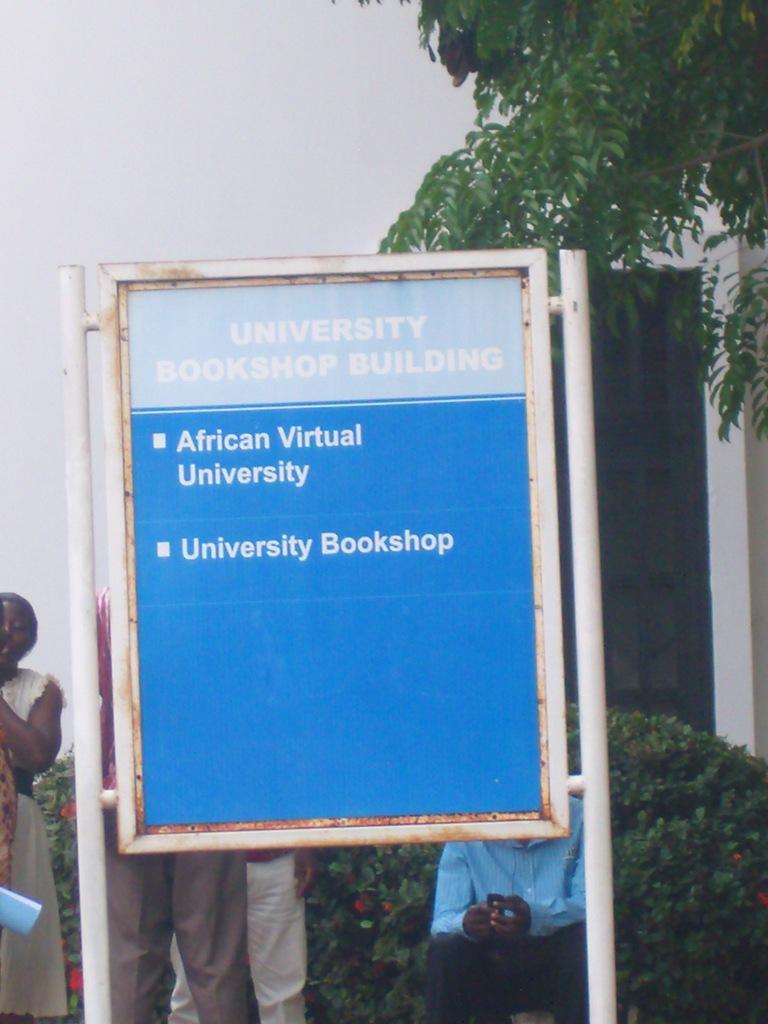Can you describe this image briefly? There is a board in the middle of this image, and there are some plants and some persons are standing in the background, and there is a tree on the right side of this image and there is a sky at the top of this image. 